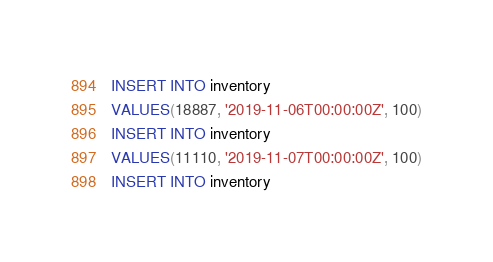<code> <loc_0><loc_0><loc_500><loc_500><_SQL_>INSERT INTO inventory
VALUES(18887, '2019-11-06T00:00:00Z', 100)
INSERT INTO inventory
VALUES(11110, '2019-11-07T00:00:00Z', 100)
INSERT INTO inventory</code> 